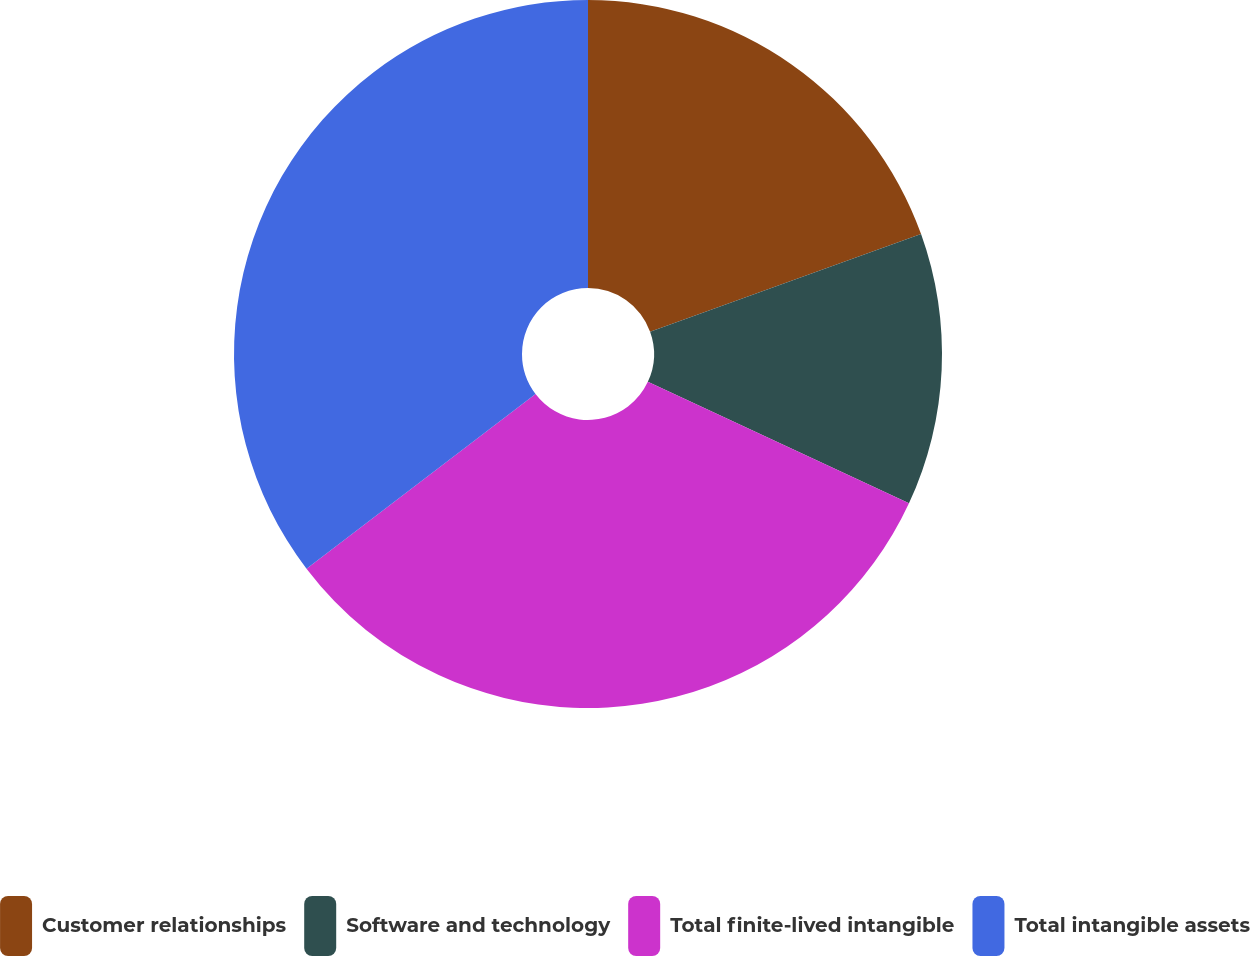Convert chart to OTSL. <chart><loc_0><loc_0><loc_500><loc_500><pie_chart><fcel>Customer relationships<fcel>Software and technology<fcel>Total finite-lived intangible<fcel>Total intangible assets<nl><fcel>19.5%<fcel>12.43%<fcel>32.7%<fcel>35.37%<nl></chart> 